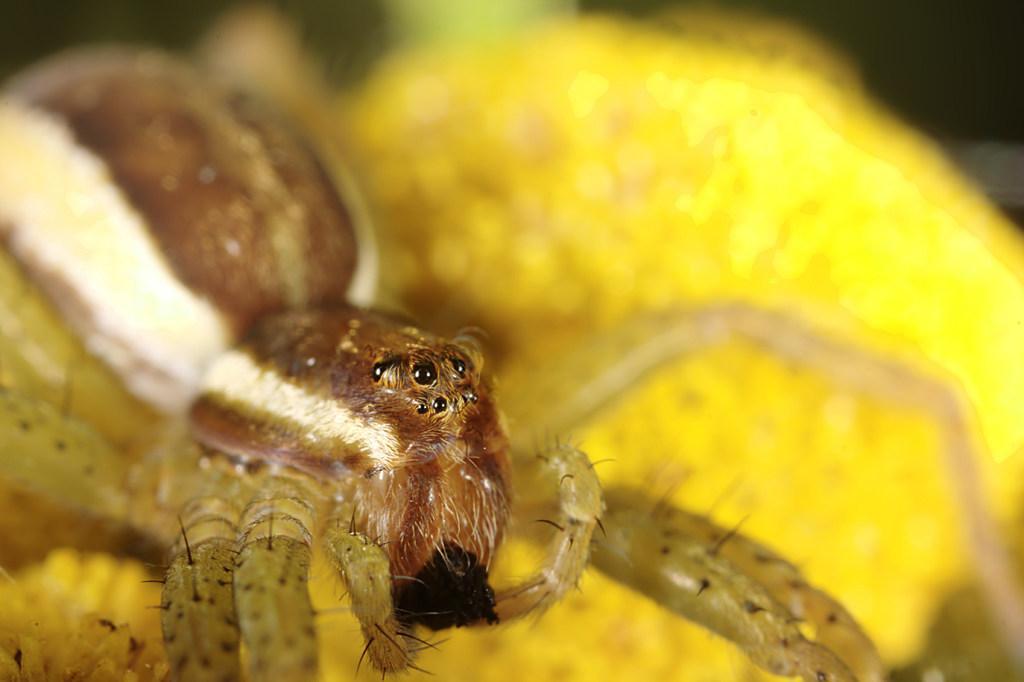In one or two sentences, can you explain what this image depicts? In the picture there is a zoom in view of an insect and the background of the insect is blur. 